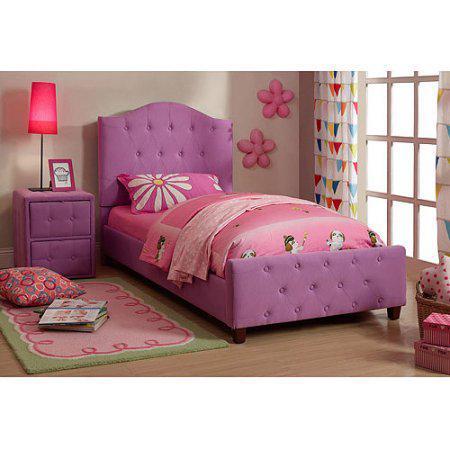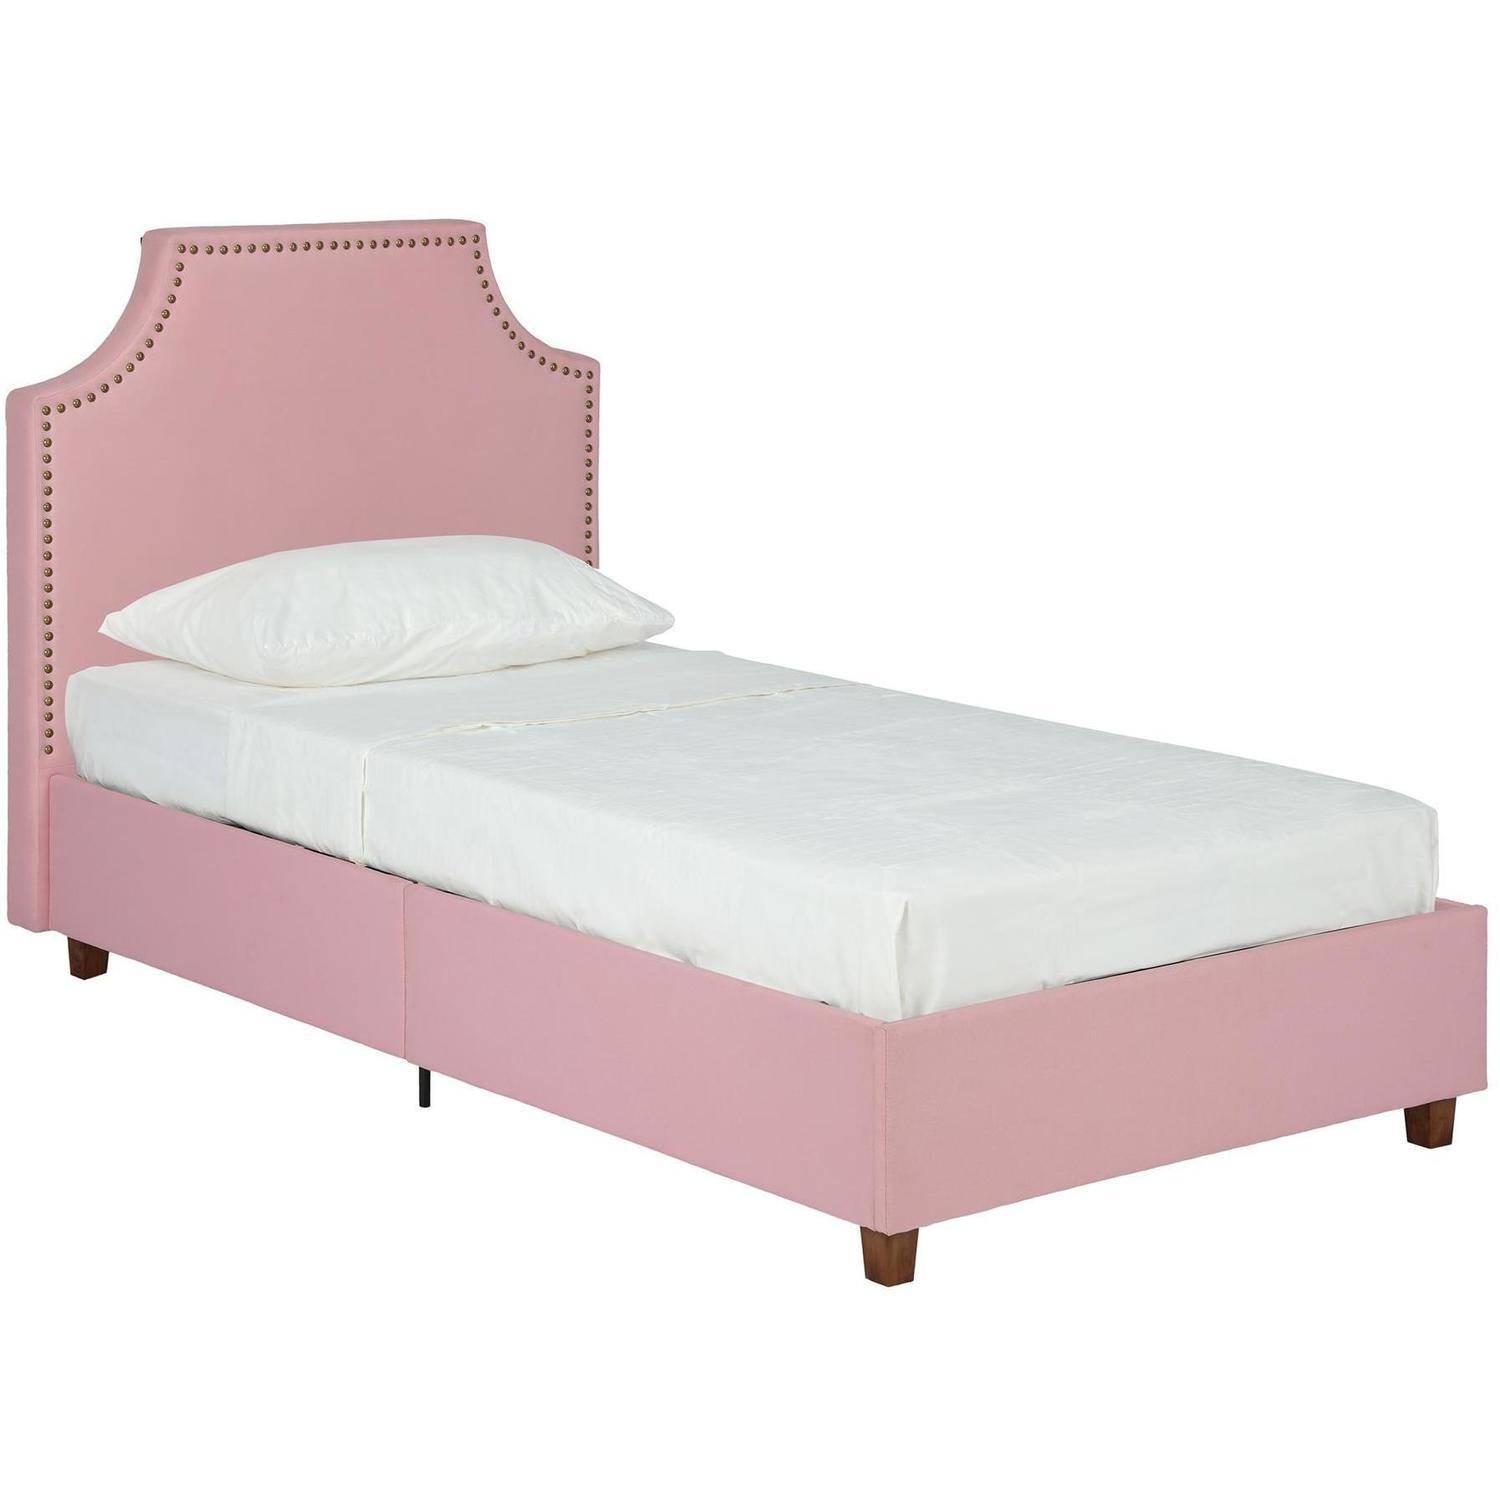The first image is the image on the left, the second image is the image on the right. Analyze the images presented: Is the assertion "Both head- and foot-board of one bed are upholstered and tufted with purple fabric." valid? Answer yes or no. Yes. The first image is the image on the left, the second image is the image on the right. Given the left and right images, does the statement "There is a single pink bed with a pull out trundle bed attached underneath it" hold true? Answer yes or no. No. 